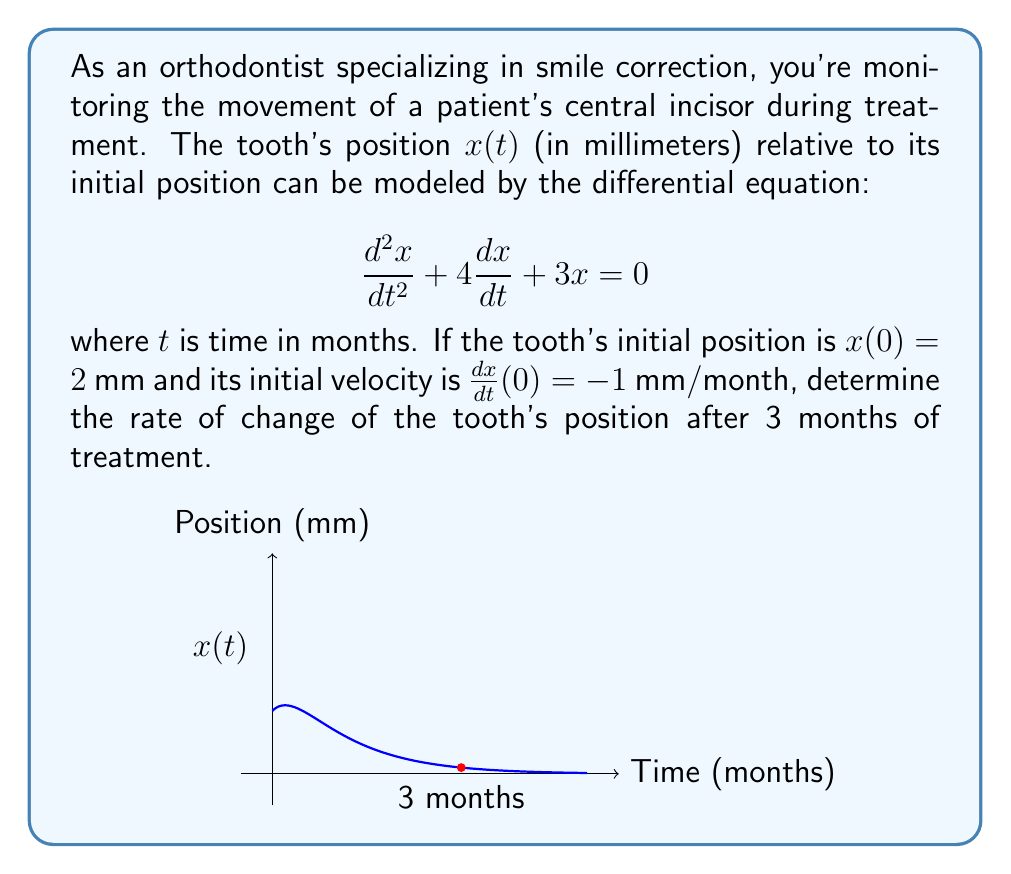Solve this math problem. Let's approach this step-by-step:

1) The general solution to this second-order linear differential equation is:
   $$x(t) = c_1e^{-t} + c_2e^{-3t}$$

2) To find $c_1$ and $c_2$, we use the initial conditions:
   
   At $t=0$: $x(0) = 2$, so $c_1 + c_2 = 2$ ... (Eq. 1)
   
   $\frac{dx}{dt} = -c_1e^{-t} - 3c_2e^{-3t}$
   
   At $t=0$: $\frac{dx}{dt}(0) = -1$, so $-c_1 - 3c_2 = -1$ ... (Eq. 2)

3) Solving Eq. 1 and Eq. 2 simultaneously:
   From Eq. 1: $c_2 = 2 - c_1$
   Substituting in Eq. 2: $-c_1 - 3(2-c_1) = -1$
   $-c_1 - 6 + 3c_1 = -1$
   $2c_1 = 5$
   $c_1 = \frac{5}{2}$
   
   Then, $c_2 = 2 - \frac{5}{2} = -\frac{1}{2}$

4) Therefore, the particular solution is:
   $$x(t) = \frac{5}{2}e^{-t} - \frac{1}{2}e^{-3t}$$

5) To find the rate of change at $t=3$, we differentiate $x(t)$:
   $$\frac{dx}{dt} = -\frac{5}{2}e^{-t} + \frac{3}{2}e^{-3t}$$

6) Evaluating at $t=3$:
   $$\frac{dx}{dt}(3) = -\frac{5}{2}e^{-3} + \frac{3}{2}e^{-9}$$

7) Calculating the numerical value:
   $$\frac{dx}{dt}(3) \approx -0.1226 + 0.0002 \approx -0.1224$$
Answer: $-0.1224$ mm/month 